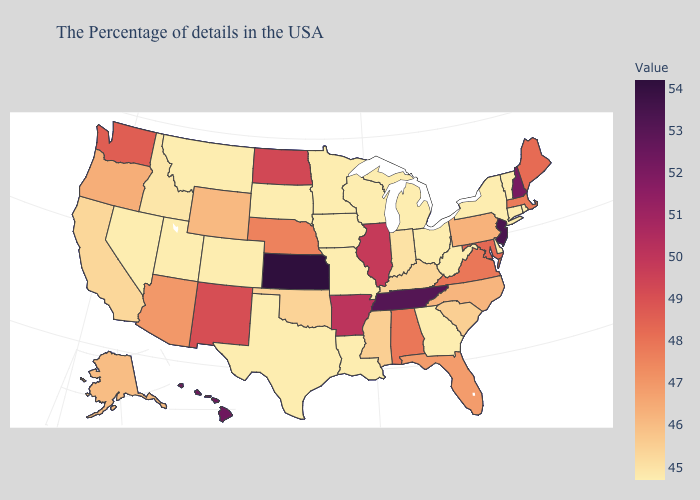Among the states that border New Hampshire , does Vermont have the lowest value?
Concise answer only. Yes. Does Arizona have a higher value than Washington?
Quick response, please. No. Does Iowa have the lowest value in the USA?
Keep it brief. Yes. Does New Mexico have the highest value in the West?
Answer briefly. No. Which states have the lowest value in the USA?
Give a very brief answer. Rhode Island, Vermont, Connecticut, New York, Delaware, West Virginia, Ohio, Georgia, Michigan, Wisconsin, Louisiana, Missouri, Minnesota, Iowa, Texas, South Dakota, Colorado, Utah, Montana, Nevada. Which states have the highest value in the USA?
Quick response, please. Kansas. 